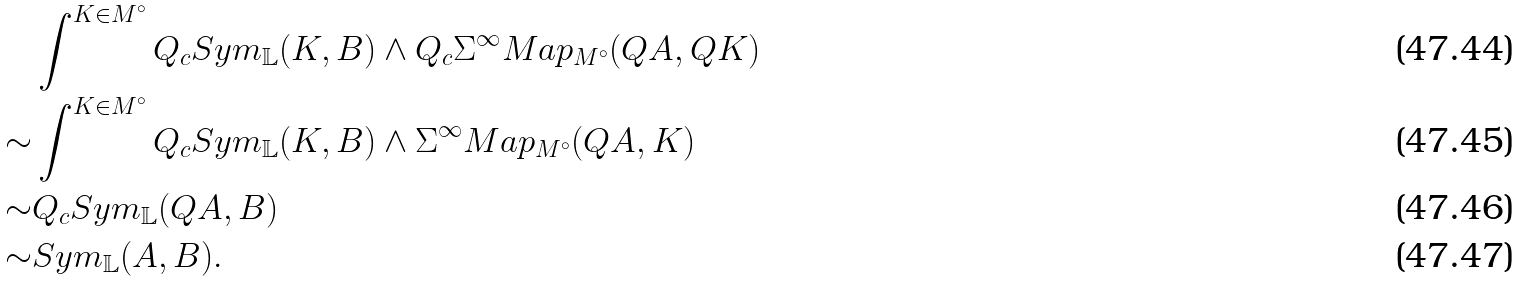Convert formula to latex. <formula><loc_0><loc_0><loc_500><loc_500>& \int ^ { K \in M ^ { \circ } } Q _ { c } S y m _ { \mathbb { L } } ( K , B ) \wedge Q _ { c } \Sigma ^ { \infty } M a p _ { M ^ { \circ } } ( Q A , Q K ) \\ \sim & \int ^ { K \in M ^ { \circ } } Q _ { c } S y m _ { \mathbb { L } } ( K , B ) \wedge \Sigma ^ { \infty } M a p _ { M ^ { \circ } } ( Q A , K ) \\ \sim & Q _ { c } S y m _ { \mathbb { L } } ( Q A , B ) \\ \sim & S y m _ { \mathbb { L } } ( A , B ) .</formula> 